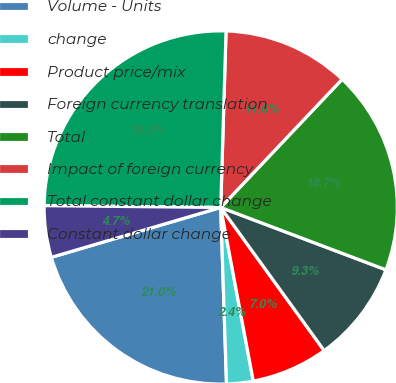Convert chart to OTSL. <chart><loc_0><loc_0><loc_500><loc_500><pie_chart><fcel>Volume - Units<fcel>change<fcel>Product price/mix<fcel>Foreign currency translation<fcel>Total<fcel>Impact of foreign currency<fcel>Total constant dollar change<fcel>Constant dollar change<nl><fcel>20.97%<fcel>2.43%<fcel>7.01%<fcel>9.3%<fcel>18.68%<fcel>11.59%<fcel>25.32%<fcel>4.72%<nl></chart> 